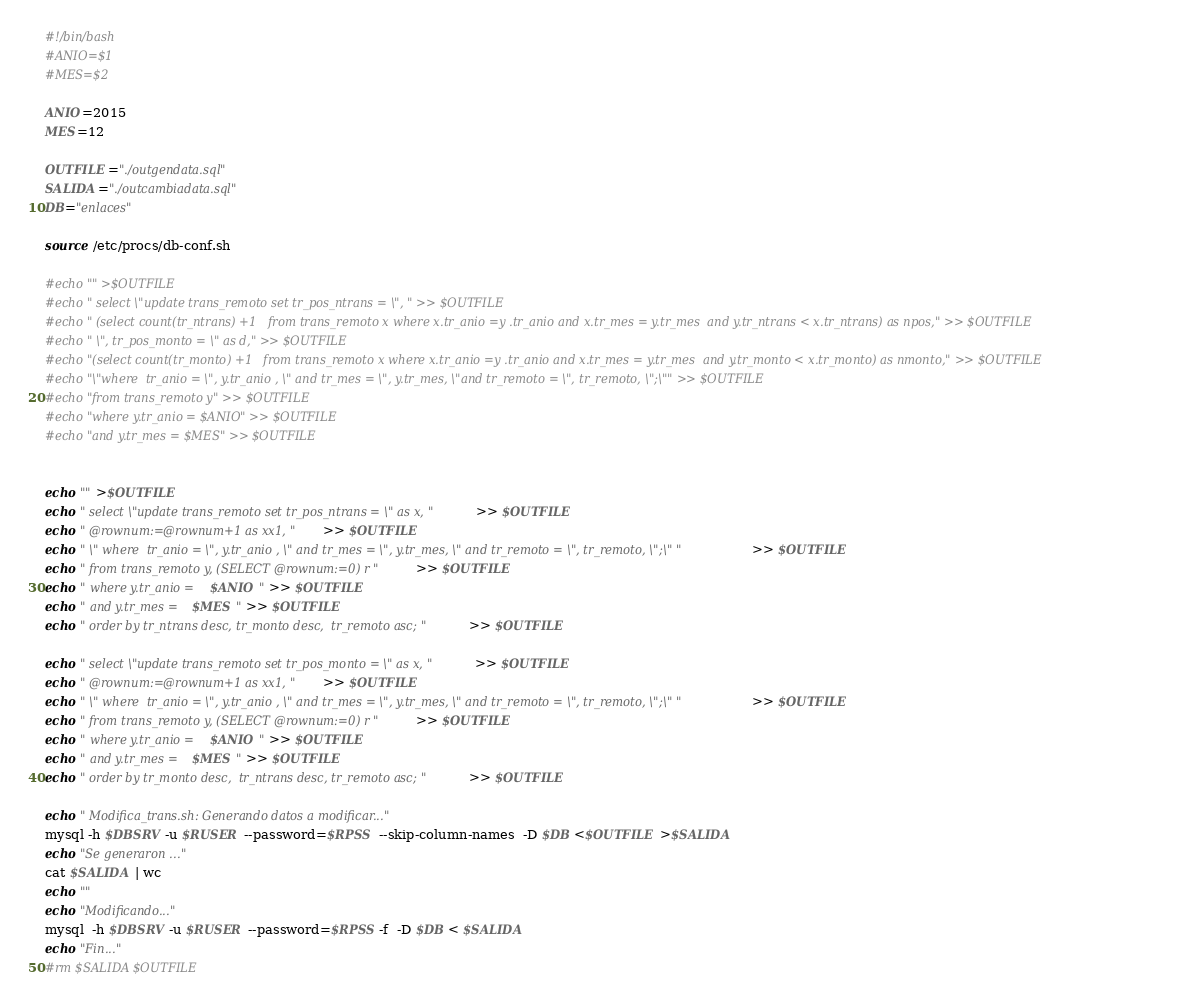<code> <loc_0><loc_0><loc_500><loc_500><_Bash_>#!/bin/bash
#ANIO=$1
#MES=$2

ANIO=2015
MES=12

OUTFILE="./outgendata.sql"
SALIDA="./outcambiadata.sql"
DB="enlaces"

source /etc/procs/db-conf.sh

#echo "" >$OUTFILE
#echo " select \"update trans_remoto set tr_pos_ntrans = \", " >> $OUTFILE
#echo " (select count(tr_ntrans) +1   from trans_remoto x where x.tr_anio =y .tr_anio and x.tr_mes = y.tr_mes  and y.tr_ntrans < x.tr_ntrans) as npos," >> $OUTFILE
#echo " \", tr_pos_monto = \" as d," >> $OUTFILE
#echo "(select count(tr_monto) +1   from trans_remoto x where x.tr_anio =y .tr_anio and x.tr_mes = y.tr_mes  and y.tr_monto < x.tr_monto) as nmonto," >> $OUTFILE
#echo "\"where  tr_anio = \", y.tr_anio , \" and tr_mes = \", y.tr_mes, \"and tr_remoto = \", tr_remoto, \";\"" >> $OUTFILE
#echo "from trans_remoto y" >> $OUTFILE
#echo "where y.tr_anio = $ANIO" >> $OUTFILE
#echo "and y.tr_mes = $MES" >> $OUTFILE


echo "" >$OUTFILE
echo " select \"update trans_remoto set tr_pos_ntrans = \" as x, " >> $OUTFILE
echo " @rownum:=@rownum+1 as xx1, " >> $OUTFILE
echo " \" where  tr_anio = \", y.tr_anio , \" and tr_mes = \", y.tr_mes, \" and tr_remoto = \", tr_remoto, \";\" " >> $OUTFILE
echo " from trans_remoto y, (SELECT @rownum:=0) r " >> $OUTFILE
echo " where y.tr_anio = $ANIO " >> $OUTFILE
echo " and y.tr_mes = $MES " >> $OUTFILE
echo " order by tr_ntrans desc, tr_monto desc,  tr_remoto asc; " >> $OUTFILE

echo " select \"update trans_remoto set tr_pos_monto = \" as x, " >> $OUTFILE
echo " @rownum:=@rownum+1 as xx1, " >> $OUTFILE
echo " \" where  tr_anio = \", y.tr_anio , \" and tr_mes = \", y.tr_mes, \" and tr_remoto = \", tr_remoto, \";\" " >> $OUTFILE
echo " from trans_remoto y, (SELECT @rownum:=0) r " >> $OUTFILE
echo " where y.tr_anio = $ANIO " >> $OUTFILE
echo " and y.tr_mes = $MES " >> $OUTFILE
echo " order by tr_monto desc,  tr_ntrans desc, tr_remoto asc; " >> $OUTFILE

echo " Modifica_trans.sh: Generando datos a modificar..." 
mysql -h $DBSRV -u $RUSER --password=$RPSS  --skip-column-names  -D $DB <$OUTFILE >$SALIDA
echo "Se generaron ..." 
cat $SALIDA | wc
echo ""
echo "Modificando..." 
mysql  -h $DBSRV -u $RUSER --password=$RPSS -f  -D $DB < $SALIDA
echo "Fin..." 
#rm $SALIDA $OUTFILE 

</code> 